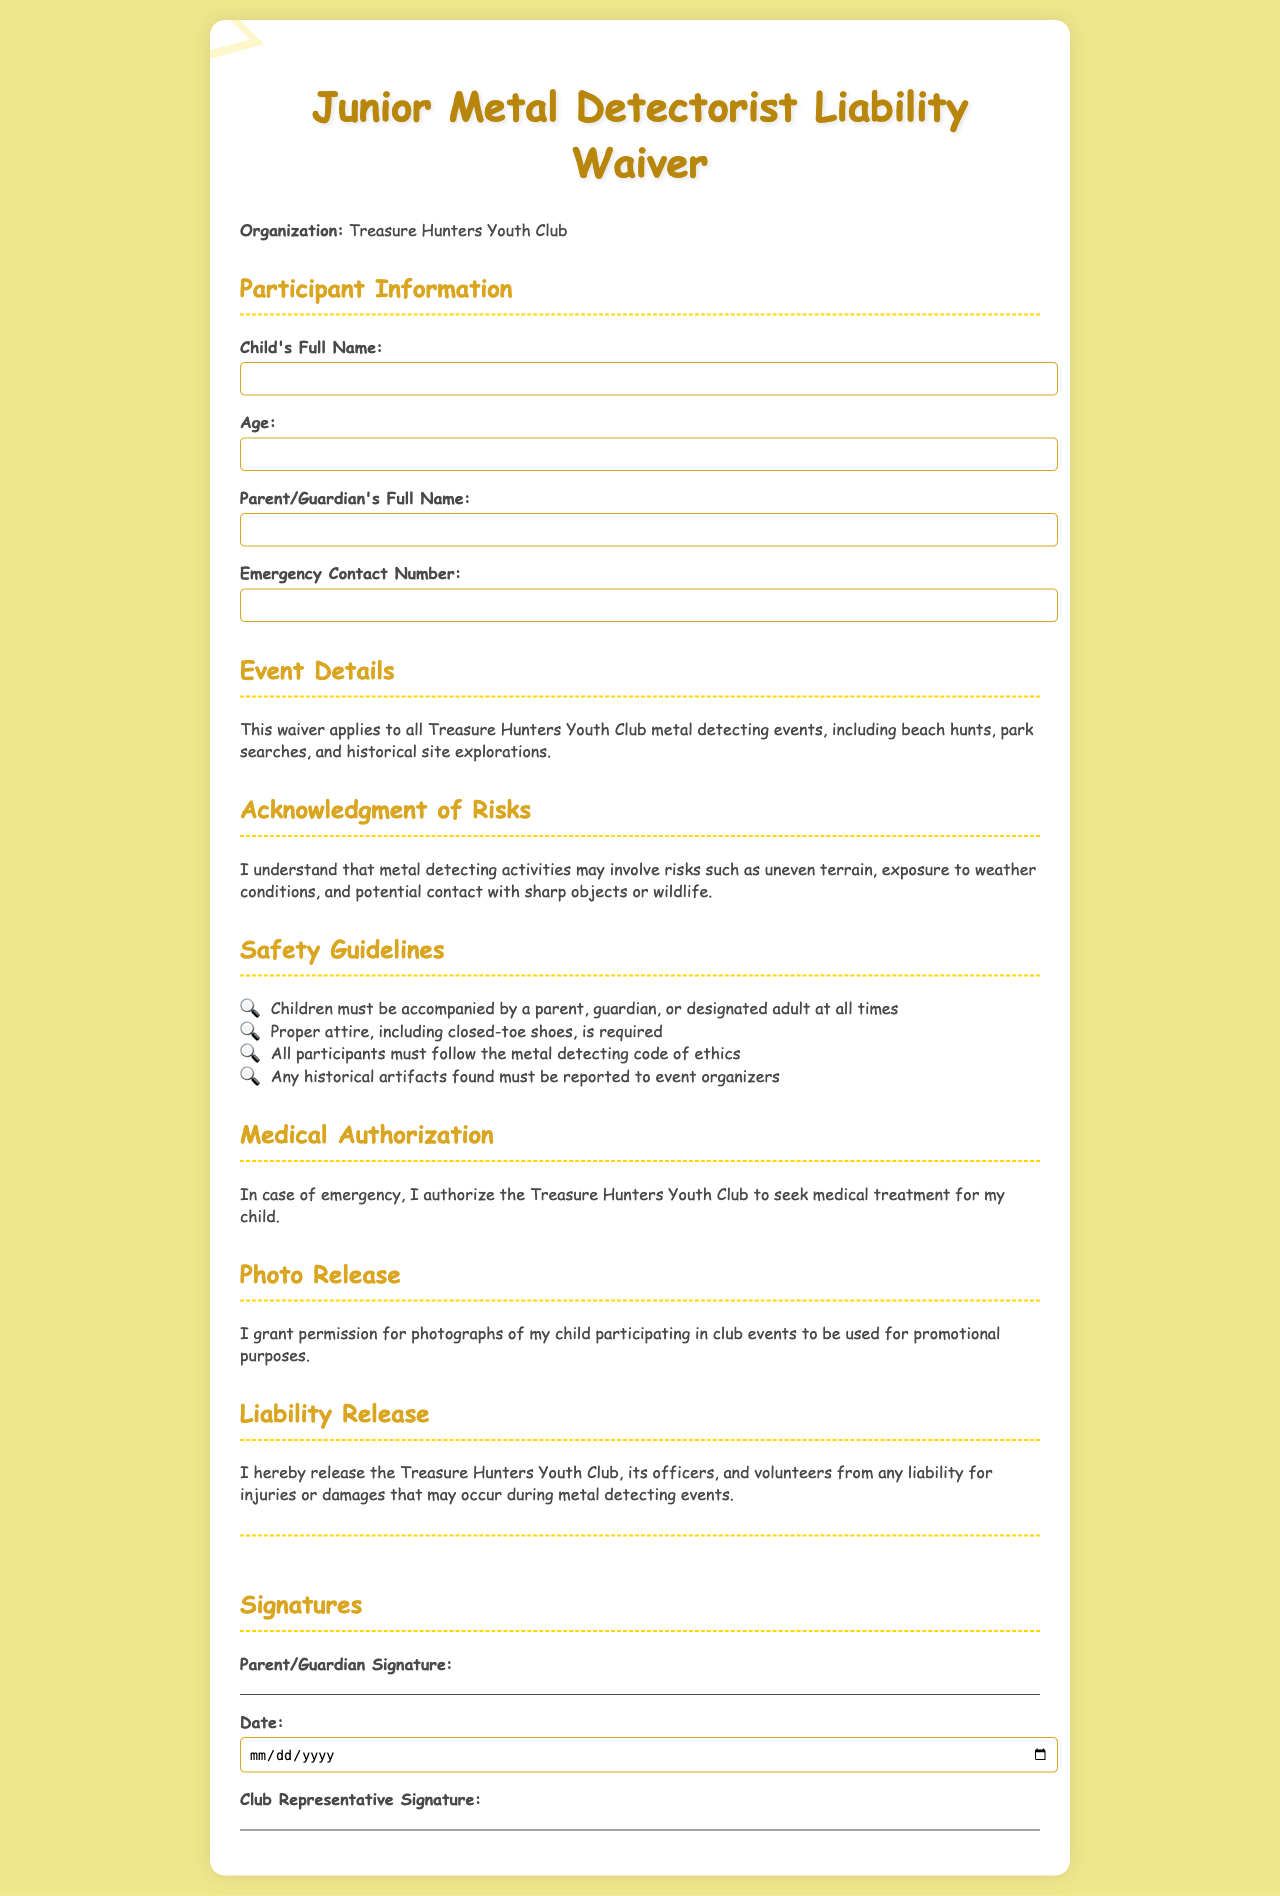What is the name of the organization? The name of the organization is mentioned at the beginning of the document.
Answer: Treasure Hunters Youth Club What is the required attire for participants? The document states specific attire requirements for safety during activities.
Answer: Closed-toe shoes What must children be accompanied by? The safety guidelines indicate accompaniment requirements for children.
Answer: Parent, guardian, or designated adult How old must the participant be? The document has a field specifically for the age of the participant.
Answer: Number not specified (but implied to be a minor, typically under 18) What type of events does this waiver apply to? The document lists the types of events for which the waiver is relevant.
Answer: Metal detecting events What medical action can the club take in emergencies? The document gives the organization authority regarding medical treatment for the child.
Answer: Seek medical treatment What must be reported if found during the events? The guidelines mention responsibilities regarding artifacts discovered.
Answer: Historical artifacts What does the waiver release the club from? The liabilities that the waiver addresses will be mentioned in the document.
Answer: Liability for injuries or damages 